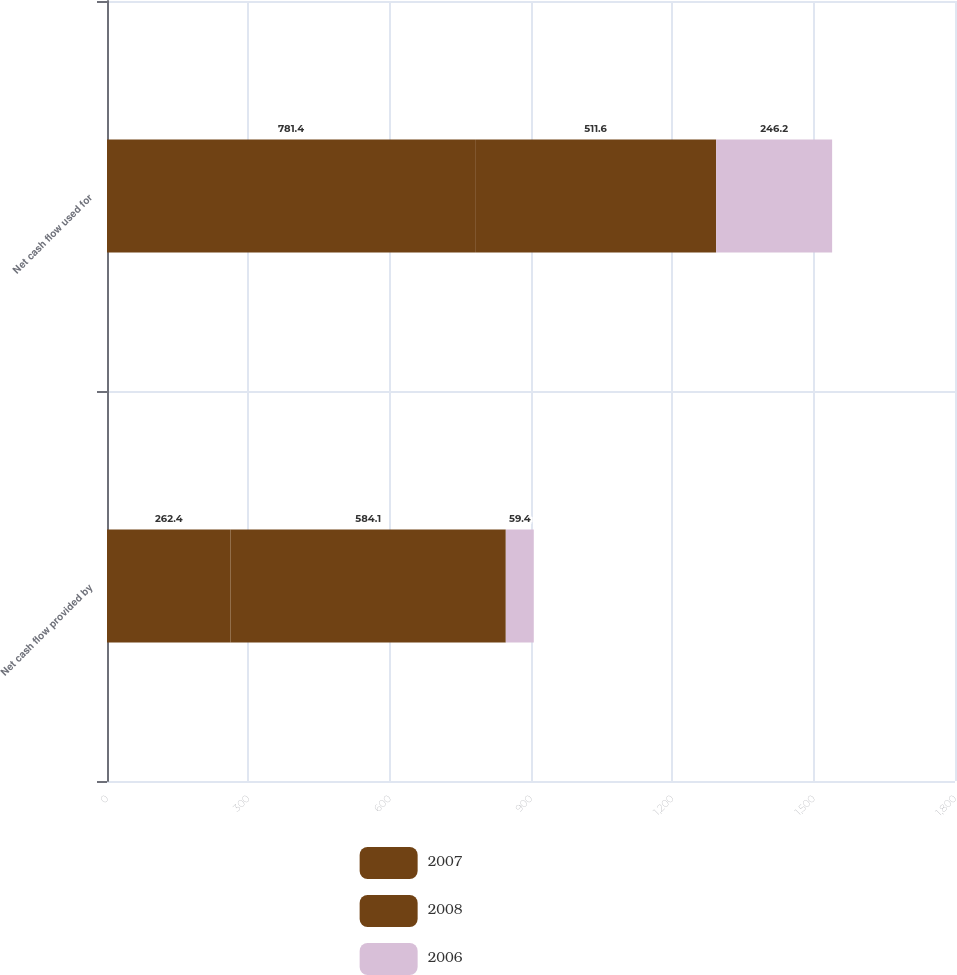<chart> <loc_0><loc_0><loc_500><loc_500><stacked_bar_chart><ecel><fcel>Net cash flow provided by<fcel>Net cash flow used for<nl><fcel>2007<fcel>262.4<fcel>781.4<nl><fcel>2008<fcel>584.1<fcel>511.6<nl><fcel>2006<fcel>59.4<fcel>246.2<nl></chart> 